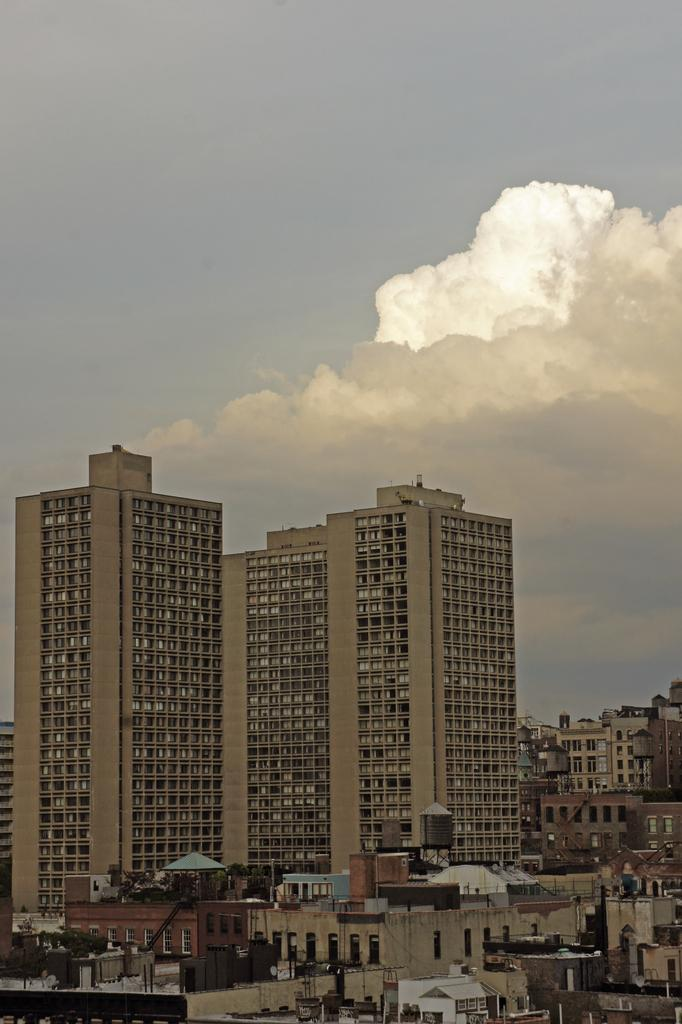What types of structures are present in the image? There are buildings and houses in the picture. What is visible at the top of the image? The sky is visible at the top of the picture. How does the sky appear in the image? The sky appears to be cloudy in the image. What type of dinner is being served at the protest in the image? There is no dinner or protest present in the image; it features buildings, houses, and a cloudy sky. 